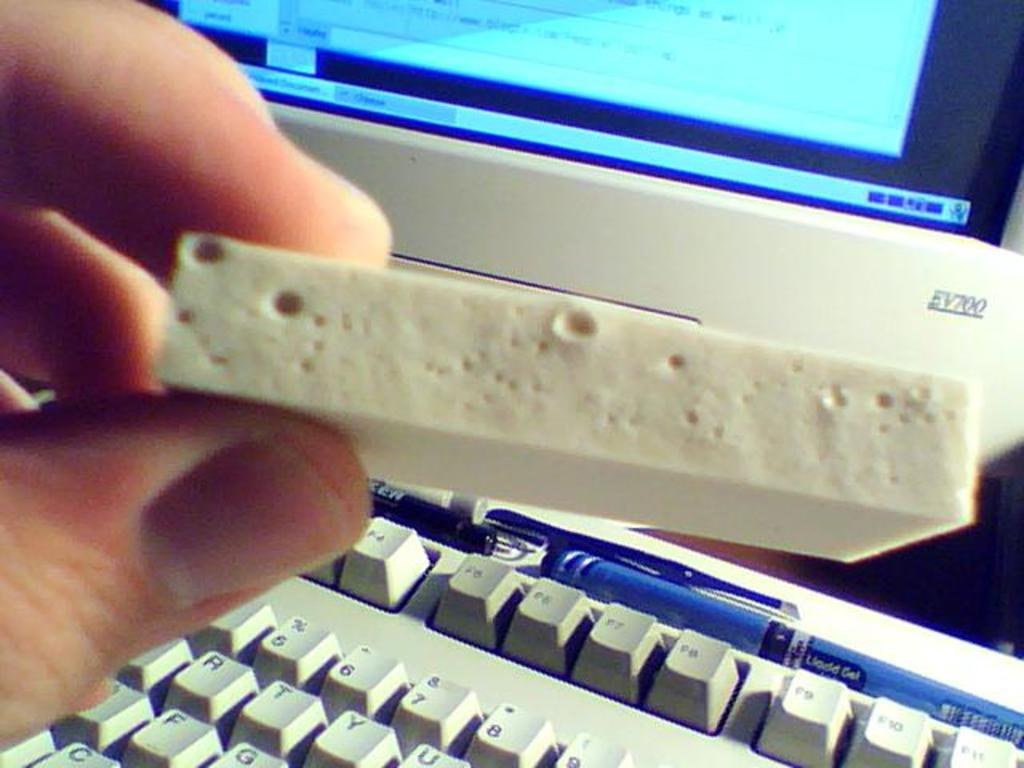<image>
Share a concise interpretation of the image provided. the number 7 is on the keyboard with a screen above it 